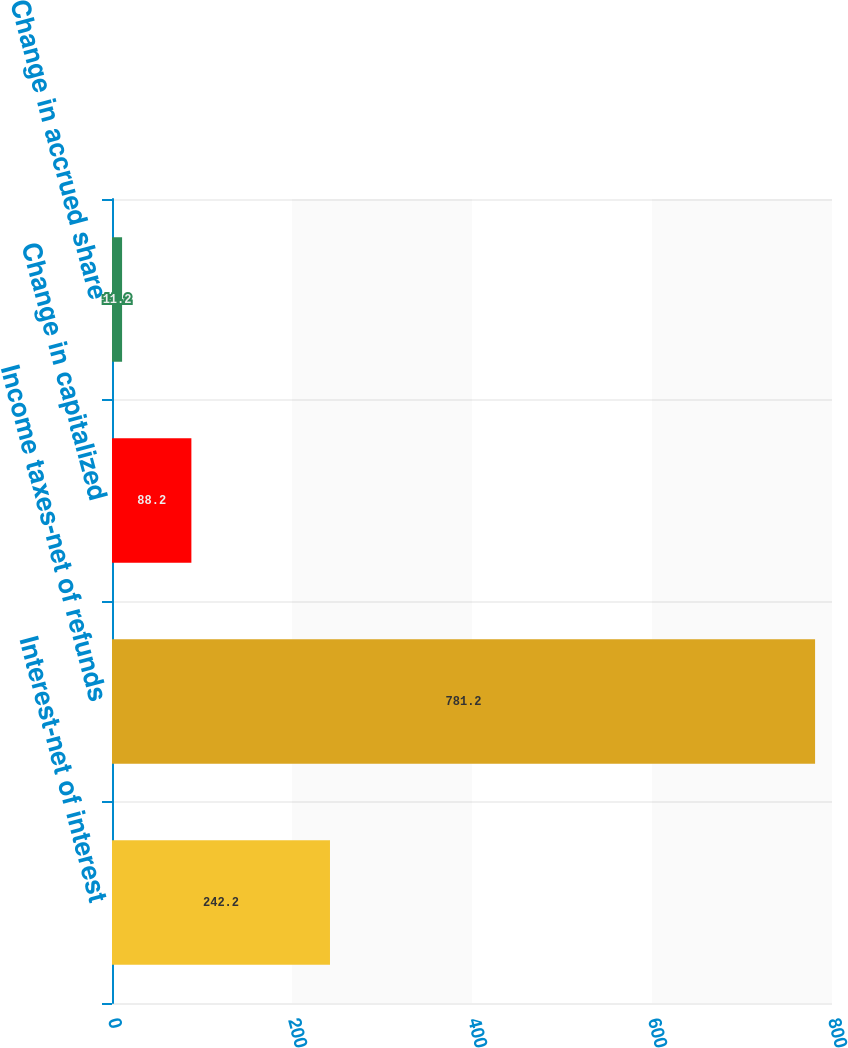Convert chart. <chart><loc_0><loc_0><loc_500><loc_500><bar_chart><fcel>Interest-net of interest<fcel>Income taxes-net of refunds<fcel>Change in capitalized<fcel>Change in accrued share<nl><fcel>242.2<fcel>781.2<fcel>88.2<fcel>11.2<nl></chart> 